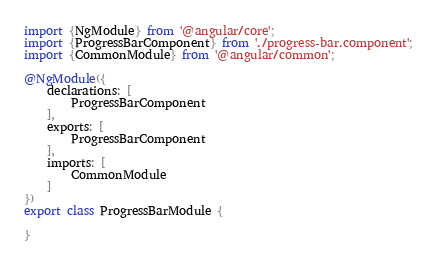Convert code to text. <code><loc_0><loc_0><loc_500><loc_500><_TypeScript_>import {NgModule} from '@angular/core';
import {ProgressBarComponent} from './progress-bar.component';
import {CommonModule} from '@angular/common';

@NgModule({
    declarations: [
        ProgressBarComponent
    ],
    exports: [
        ProgressBarComponent
    ],
    imports: [
        CommonModule
    ]
})
export class ProgressBarModule {

}
</code> 